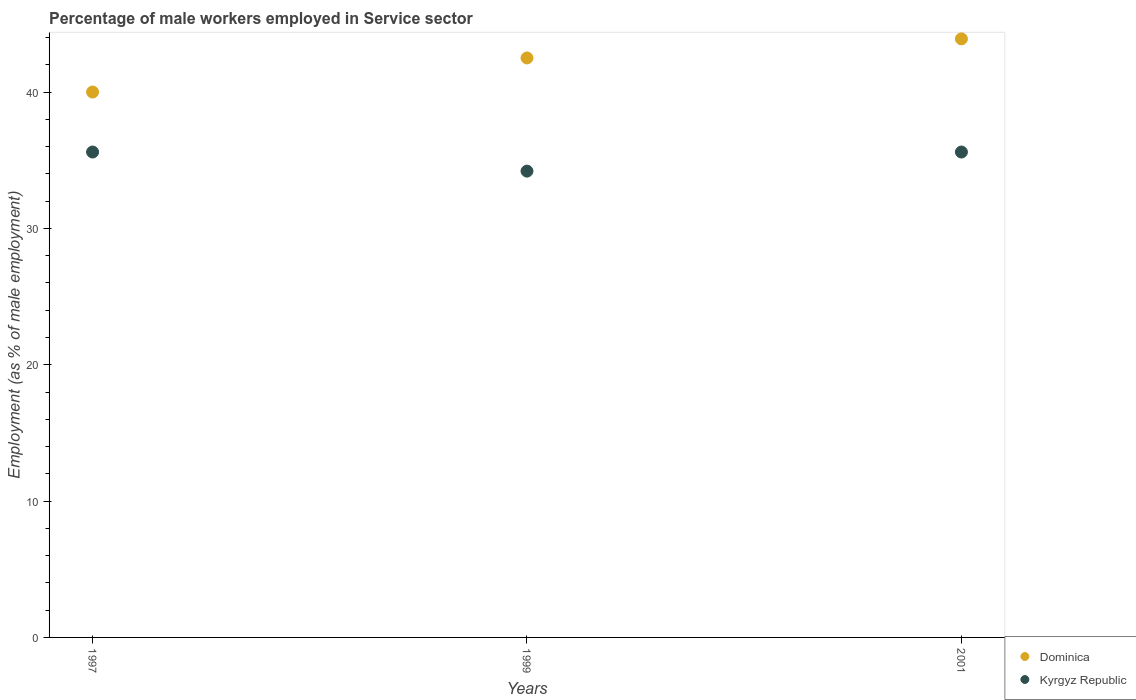How many different coloured dotlines are there?
Give a very brief answer. 2. Is the number of dotlines equal to the number of legend labels?
Offer a terse response. Yes. What is the percentage of male workers employed in Service sector in Kyrgyz Republic in 1997?
Offer a very short reply. 35.6. Across all years, what is the maximum percentage of male workers employed in Service sector in Kyrgyz Republic?
Your answer should be very brief. 35.6. Across all years, what is the minimum percentage of male workers employed in Service sector in Dominica?
Your answer should be very brief. 40. In which year was the percentage of male workers employed in Service sector in Dominica minimum?
Your response must be concise. 1997. What is the total percentage of male workers employed in Service sector in Dominica in the graph?
Keep it short and to the point. 126.4. What is the difference between the percentage of male workers employed in Service sector in Dominica in 1999 and that in 2001?
Your answer should be very brief. -1.4. What is the difference between the percentage of male workers employed in Service sector in Kyrgyz Republic in 1999 and the percentage of male workers employed in Service sector in Dominica in 2001?
Offer a very short reply. -9.7. What is the average percentage of male workers employed in Service sector in Kyrgyz Republic per year?
Your response must be concise. 35.13. In the year 2001, what is the difference between the percentage of male workers employed in Service sector in Kyrgyz Republic and percentage of male workers employed in Service sector in Dominica?
Make the answer very short. -8.3. What is the ratio of the percentage of male workers employed in Service sector in Kyrgyz Republic in 1999 to that in 2001?
Your answer should be very brief. 0.96. Is the difference between the percentage of male workers employed in Service sector in Kyrgyz Republic in 1997 and 2001 greater than the difference between the percentage of male workers employed in Service sector in Dominica in 1997 and 2001?
Your answer should be compact. Yes. What is the difference between the highest and the lowest percentage of male workers employed in Service sector in Kyrgyz Republic?
Keep it short and to the point. 1.4. In how many years, is the percentage of male workers employed in Service sector in Dominica greater than the average percentage of male workers employed in Service sector in Dominica taken over all years?
Provide a succinct answer. 2. Is the percentage of male workers employed in Service sector in Dominica strictly less than the percentage of male workers employed in Service sector in Kyrgyz Republic over the years?
Your answer should be very brief. No. How many years are there in the graph?
Offer a very short reply. 3. What is the difference between two consecutive major ticks on the Y-axis?
Keep it short and to the point. 10. Are the values on the major ticks of Y-axis written in scientific E-notation?
Give a very brief answer. No. How are the legend labels stacked?
Give a very brief answer. Vertical. What is the title of the graph?
Provide a succinct answer. Percentage of male workers employed in Service sector. Does "Congo (Democratic)" appear as one of the legend labels in the graph?
Make the answer very short. No. What is the label or title of the X-axis?
Your response must be concise. Years. What is the label or title of the Y-axis?
Your response must be concise. Employment (as % of male employment). What is the Employment (as % of male employment) of Dominica in 1997?
Your answer should be compact. 40. What is the Employment (as % of male employment) in Kyrgyz Republic in 1997?
Ensure brevity in your answer.  35.6. What is the Employment (as % of male employment) of Dominica in 1999?
Offer a terse response. 42.5. What is the Employment (as % of male employment) of Kyrgyz Republic in 1999?
Your answer should be very brief. 34.2. What is the Employment (as % of male employment) in Dominica in 2001?
Provide a short and direct response. 43.9. What is the Employment (as % of male employment) in Kyrgyz Republic in 2001?
Provide a short and direct response. 35.6. Across all years, what is the maximum Employment (as % of male employment) of Dominica?
Make the answer very short. 43.9. Across all years, what is the maximum Employment (as % of male employment) in Kyrgyz Republic?
Provide a short and direct response. 35.6. Across all years, what is the minimum Employment (as % of male employment) in Kyrgyz Republic?
Ensure brevity in your answer.  34.2. What is the total Employment (as % of male employment) in Dominica in the graph?
Your response must be concise. 126.4. What is the total Employment (as % of male employment) in Kyrgyz Republic in the graph?
Your answer should be very brief. 105.4. What is the difference between the Employment (as % of male employment) in Dominica in 1997 and that in 1999?
Offer a very short reply. -2.5. What is the difference between the Employment (as % of male employment) in Kyrgyz Republic in 1997 and that in 1999?
Your answer should be very brief. 1.4. What is the difference between the Employment (as % of male employment) of Dominica in 1997 and that in 2001?
Offer a terse response. -3.9. What is the difference between the Employment (as % of male employment) of Kyrgyz Republic in 1997 and that in 2001?
Ensure brevity in your answer.  0. What is the difference between the Employment (as % of male employment) in Dominica in 1999 and that in 2001?
Your answer should be very brief. -1.4. What is the difference between the Employment (as % of male employment) of Kyrgyz Republic in 1999 and that in 2001?
Your response must be concise. -1.4. What is the difference between the Employment (as % of male employment) of Dominica in 1997 and the Employment (as % of male employment) of Kyrgyz Republic in 1999?
Your answer should be very brief. 5.8. What is the difference between the Employment (as % of male employment) in Dominica in 1997 and the Employment (as % of male employment) in Kyrgyz Republic in 2001?
Your answer should be compact. 4.4. What is the average Employment (as % of male employment) in Dominica per year?
Your answer should be compact. 42.13. What is the average Employment (as % of male employment) in Kyrgyz Republic per year?
Give a very brief answer. 35.13. In the year 1997, what is the difference between the Employment (as % of male employment) of Dominica and Employment (as % of male employment) of Kyrgyz Republic?
Offer a terse response. 4.4. In the year 2001, what is the difference between the Employment (as % of male employment) of Dominica and Employment (as % of male employment) of Kyrgyz Republic?
Provide a succinct answer. 8.3. What is the ratio of the Employment (as % of male employment) of Dominica in 1997 to that in 1999?
Make the answer very short. 0.94. What is the ratio of the Employment (as % of male employment) in Kyrgyz Republic in 1997 to that in 1999?
Your response must be concise. 1.04. What is the ratio of the Employment (as % of male employment) in Dominica in 1997 to that in 2001?
Provide a succinct answer. 0.91. What is the ratio of the Employment (as % of male employment) in Kyrgyz Republic in 1997 to that in 2001?
Make the answer very short. 1. What is the ratio of the Employment (as % of male employment) in Dominica in 1999 to that in 2001?
Make the answer very short. 0.97. What is the ratio of the Employment (as % of male employment) in Kyrgyz Republic in 1999 to that in 2001?
Keep it short and to the point. 0.96. What is the difference between the highest and the second highest Employment (as % of male employment) of Kyrgyz Republic?
Provide a succinct answer. 0. What is the difference between the highest and the lowest Employment (as % of male employment) of Dominica?
Offer a terse response. 3.9. 